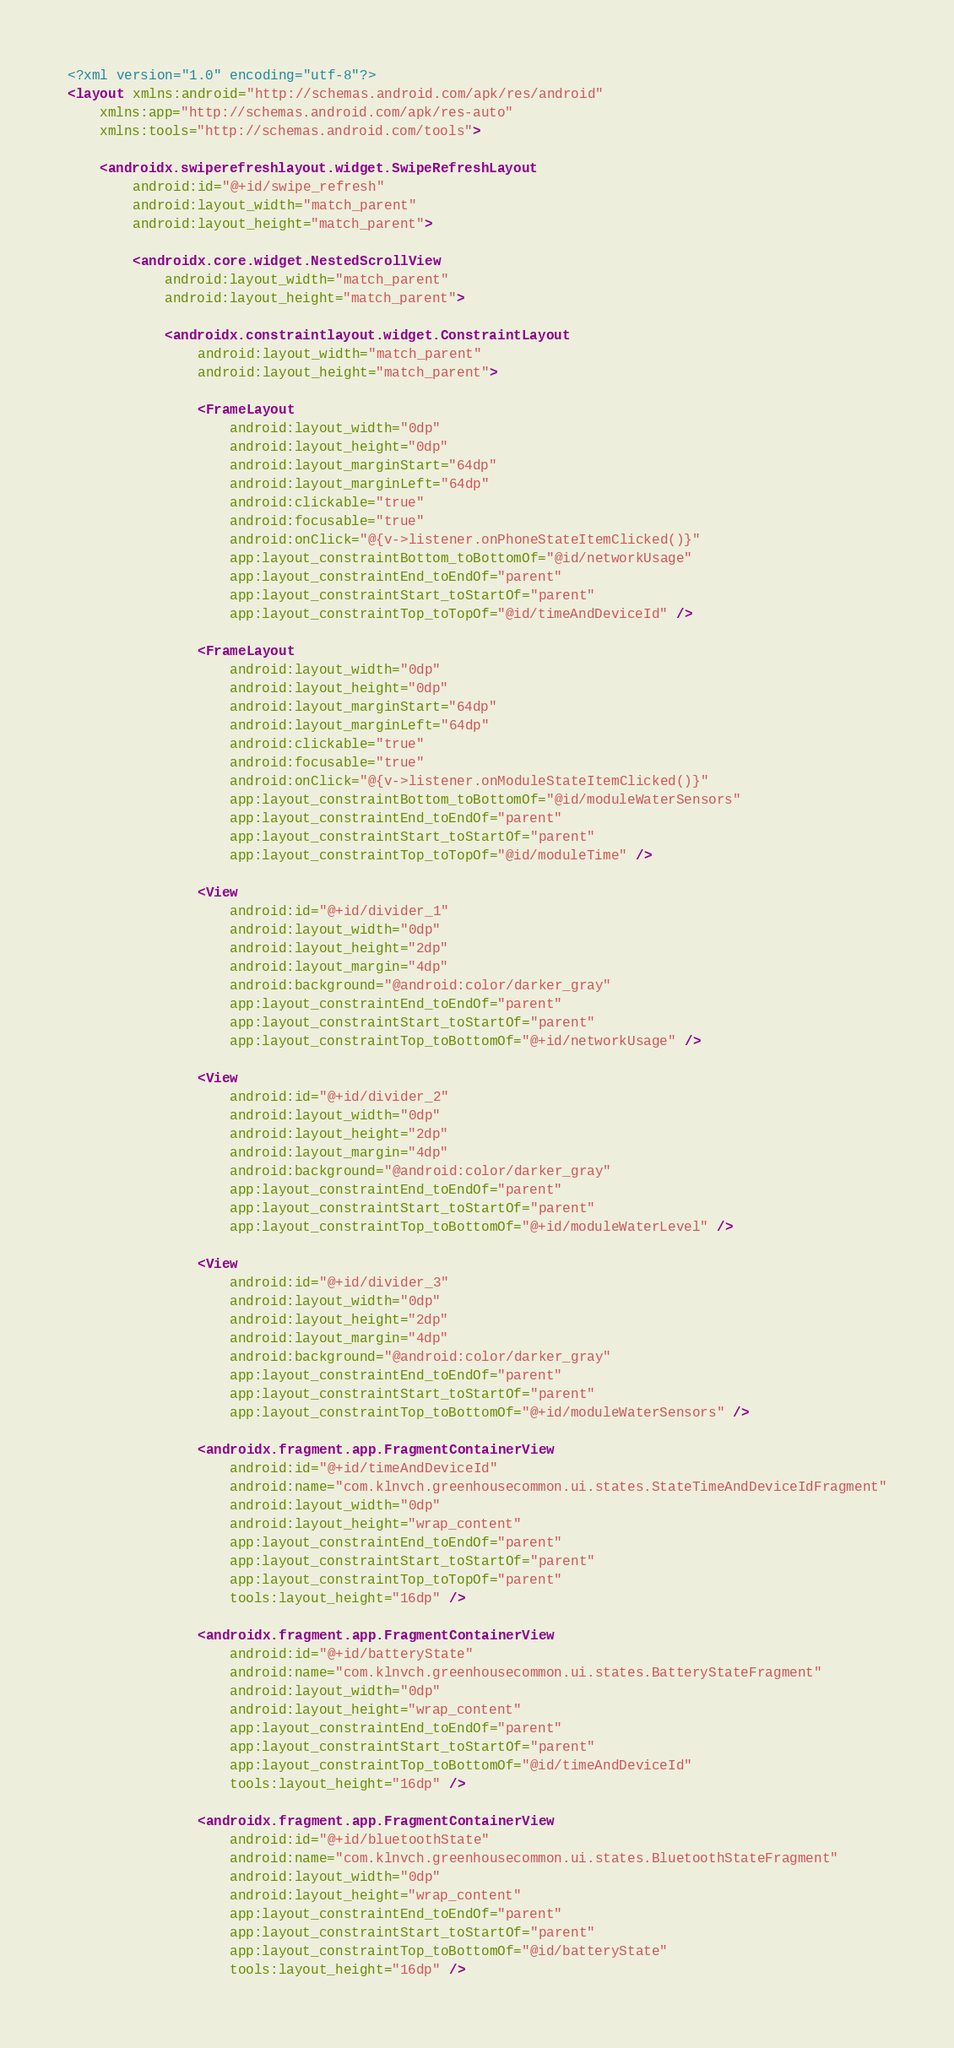<code> <loc_0><loc_0><loc_500><loc_500><_XML_><?xml version="1.0" encoding="utf-8"?>
<layout xmlns:android="http://schemas.android.com/apk/res/android"
    xmlns:app="http://schemas.android.com/apk/res-auto"
    xmlns:tools="http://schemas.android.com/tools">

    <androidx.swiperefreshlayout.widget.SwipeRefreshLayout
        android:id="@+id/swipe_refresh"
        android:layout_width="match_parent"
        android:layout_height="match_parent">

        <androidx.core.widget.NestedScrollView
            android:layout_width="match_parent"
            android:layout_height="match_parent">

            <androidx.constraintlayout.widget.ConstraintLayout
                android:layout_width="match_parent"
                android:layout_height="match_parent">

                <FrameLayout
                    android:layout_width="0dp"
                    android:layout_height="0dp"
                    android:layout_marginStart="64dp"
                    android:layout_marginLeft="64dp"
                    android:clickable="true"
                    android:focusable="true"
                    android:onClick="@{v->listener.onPhoneStateItemClicked()}"
                    app:layout_constraintBottom_toBottomOf="@id/networkUsage"
                    app:layout_constraintEnd_toEndOf="parent"
                    app:layout_constraintStart_toStartOf="parent"
                    app:layout_constraintTop_toTopOf="@id/timeAndDeviceId" />

                <FrameLayout
                    android:layout_width="0dp"
                    android:layout_height="0dp"
                    android:layout_marginStart="64dp"
                    android:layout_marginLeft="64dp"
                    android:clickable="true"
                    android:focusable="true"
                    android:onClick="@{v->listener.onModuleStateItemClicked()}"
                    app:layout_constraintBottom_toBottomOf="@id/moduleWaterSensors"
                    app:layout_constraintEnd_toEndOf="parent"
                    app:layout_constraintStart_toStartOf="parent"
                    app:layout_constraintTop_toTopOf="@id/moduleTime" />

                <View
                    android:id="@+id/divider_1"
                    android:layout_width="0dp"
                    android:layout_height="2dp"
                    android:layout_margin="4dp"
                    android:background="@android:color/darker_gray"
                    app:layout_constraintEnd_toEndOf="parent"
                    app:layout_constraintStart_toStartOf="parent"
                    app:layout_constraintTop_toBottomOf="@+id/networkUsage" />

                <View
                    android:id="@+id/divider_2"
                    android:layout_width="0dp"
                    android:layout_height="2dp"
                    android:layout_margin="4dp"
                    android:background="@android:color/darker_gray"
                    app:layout_constraintEnd_toEndOf="parent"
                    app:layout_constraintStart_toStartOf="parent"
                    app:layout_constraintTop_toBottomOf="@+id/moduleWaterLevel" />

                <View
                    android:id="@+id/divider_3"
                    android:layout_width="0dp"
                    android:layout_height="2dp"
                    android:layout_margin="4dp"
                    android:background="@android:color/darker_gray"
                    app:layout_constraintEnd_toEndOf="parent"
                    app:layout_constraintStart_toStartOf="parent"
                    app:layout_constraintTop_toBottomOf="@+id/moduleWaterSensors" />

                <androidx.fragment.app.FragmentContainerView
                    android:id="@+id/timeAndDeviceId"
                    android:name="com.klnvch.greenhousecommon.ui.states.StateTimeAndDeviceIdFragment"
                    android:layout_width="0dp"
                    android:layout_height="wrap_content"
                    app:layout_constraintEnd_toEndOf="parent"
                    app:layout_constraintStart_toStartOf="parent"
                    app:layout_constraintTop_toTopOf="parent"
                    tools:layout_height="16dp" />

                <androidx.fragment.app.FragmentContainerView
                    android:id="@+id/batteryState"
                    android:name="com.klnvch.greenhousecommon.ui.states.BatteryStateFragment"
                    android:layout_width="0dp"
                    android:layout_height="wrap_content"
                    app:layout_constraintEnd_toEndOf="parent"
                    app:layout_constraintStart_toStartOf="parent"
                    app:layout_constraintTop_toBottomOf="@id/timeAndDeviceId"
                    tools:layout_height="16dp" />

                <androidx.fragment.app.FragmentContainerView
                    android:id="@+id/bluetoothState"
                    android:name="com.klnvch.greenhousecommon.ui.states.BluetoothStateFragment"
                    android:layout_width="0dp"
                    android:layout_height="wrap_content"
                    app:layout_constraintEnd_toEndOf="parent"
                    app:layout_constraintStart_toStartOf="parent"
                    app:layout_constraintTop_toBottomOf="@id/batteryState"
                    tools:layout_height="16dp" />
</code> 